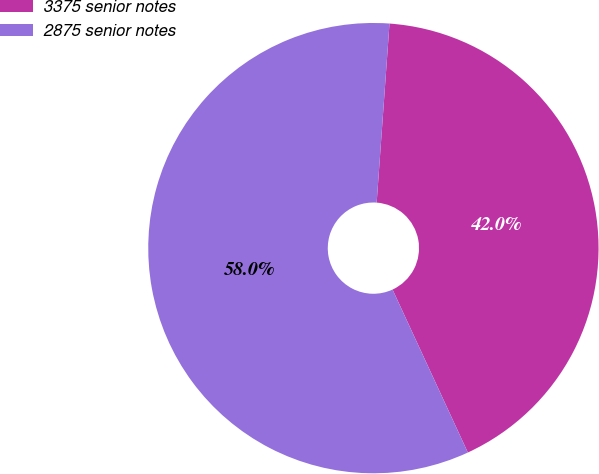<chart> <loc_0><loc_0><loc_500><loc_500><pie_chart><fcel>3375 senior notes<fcel>2875 senior notes<nl><fcel>41.97%<fcel>58.03%<nl></chart> 